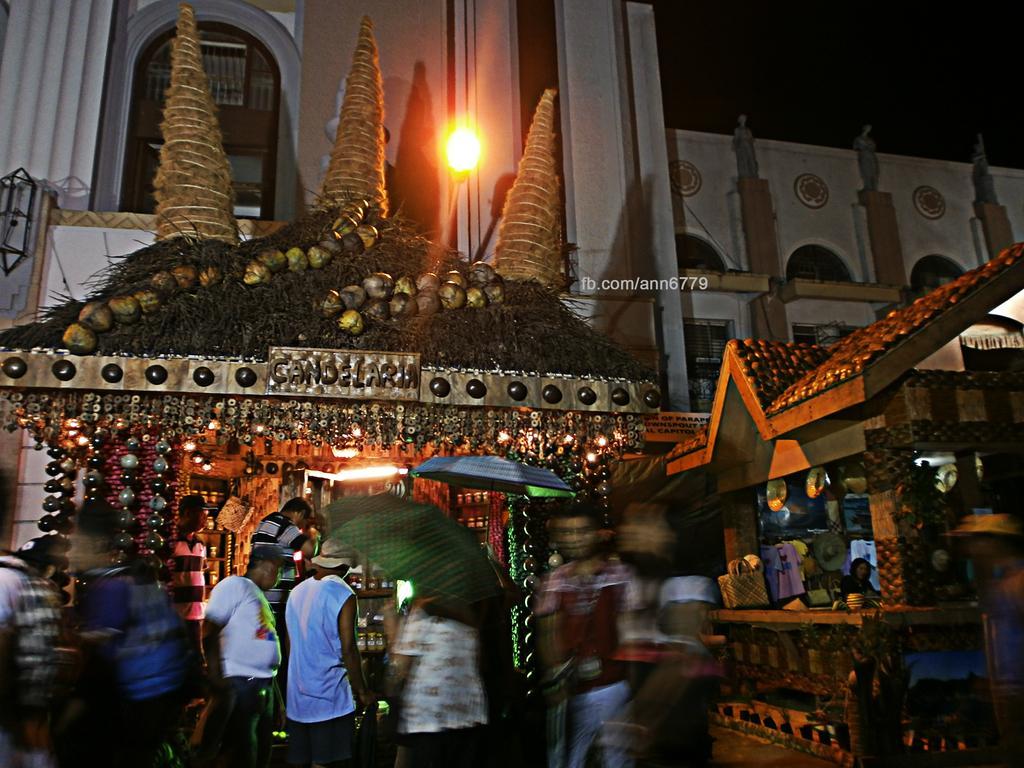Can you describe this image briefly? In this picture at the bottom there are some people who are walking and two of them are holding umbrellas, and in the background there are some stores. In that stores there are some pearls, baskets, bags, clothes and some objects. In the background there are some buildings and light. 